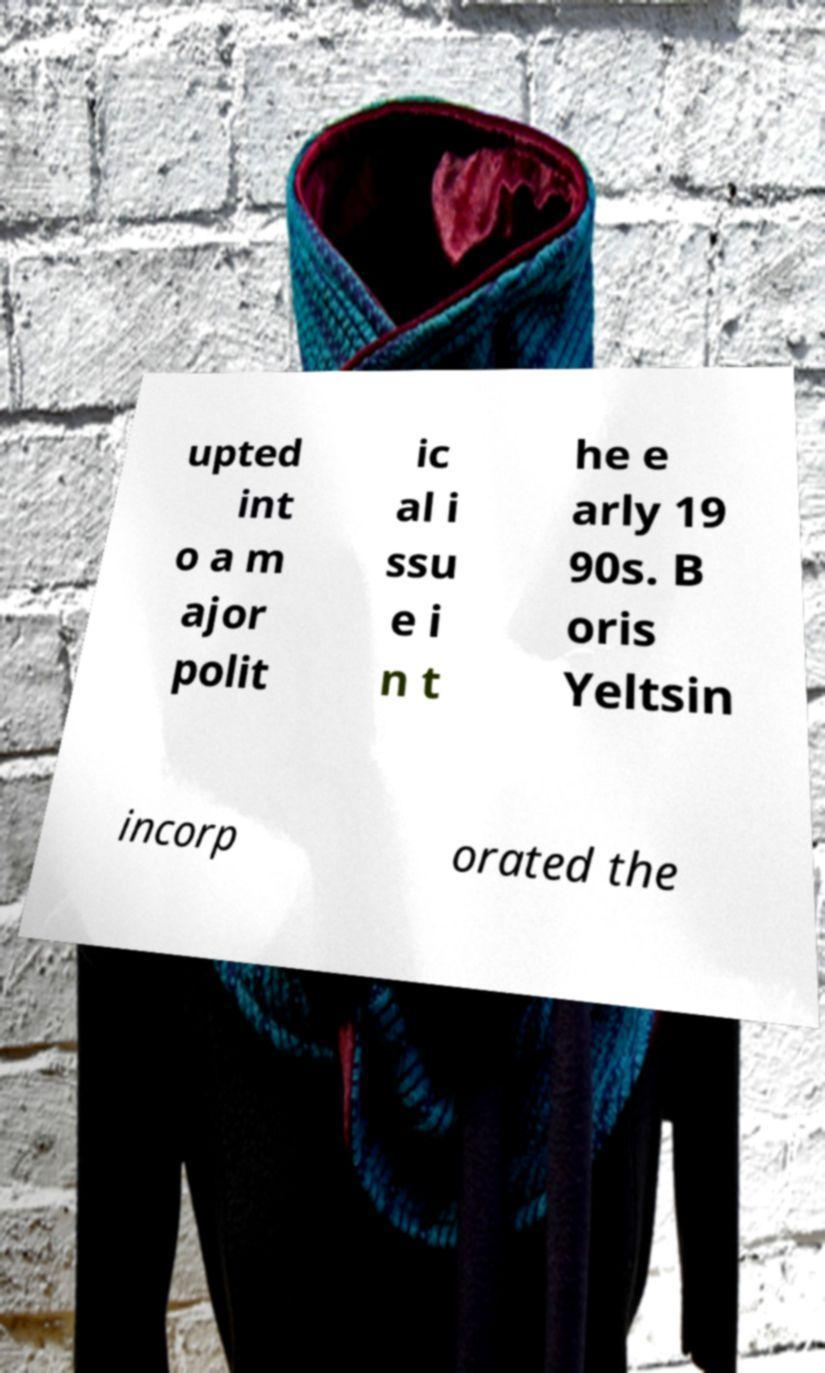Could you assist in decoding the text presented in this image and type it out clearly? upted int o a m ajor polit ic al i ssu e i n t he e arly 19 90s. B oris Yeltsin incorp orated the 